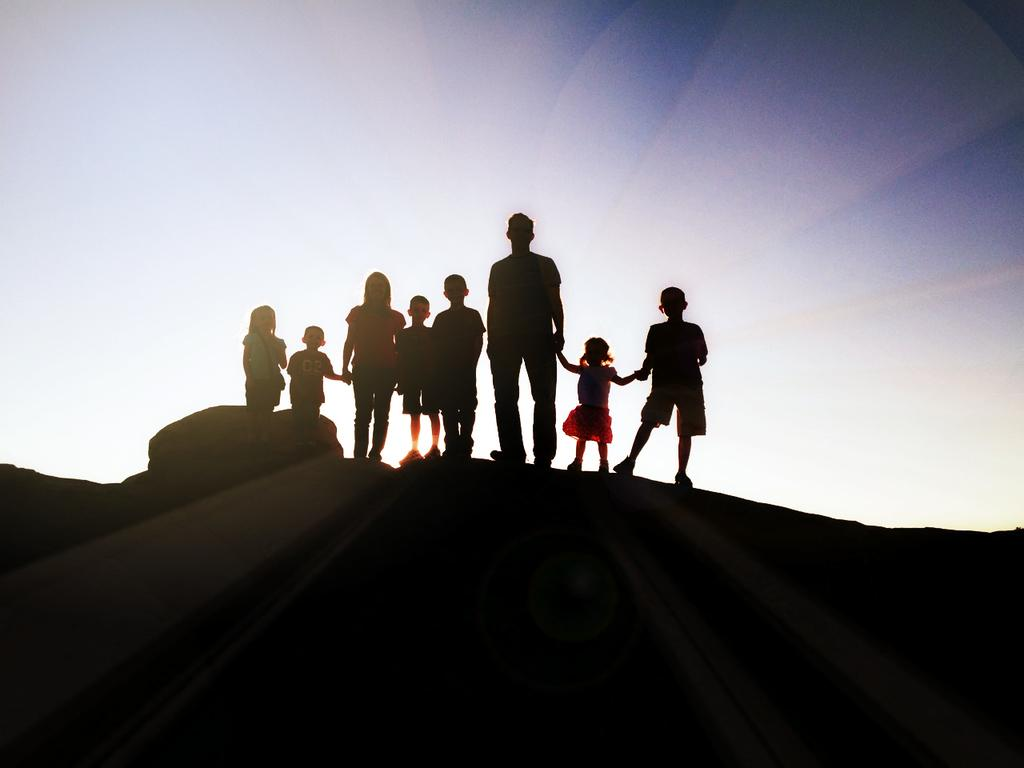How many people are in the image? There is a group of people in the image. What are the people standing on? The people are standing on a rock. What can be seen in the background of the image? The sky is visible in the background of the image. What type of liquid is being poured from the window in the image? There is no liquid or window present in the image. 